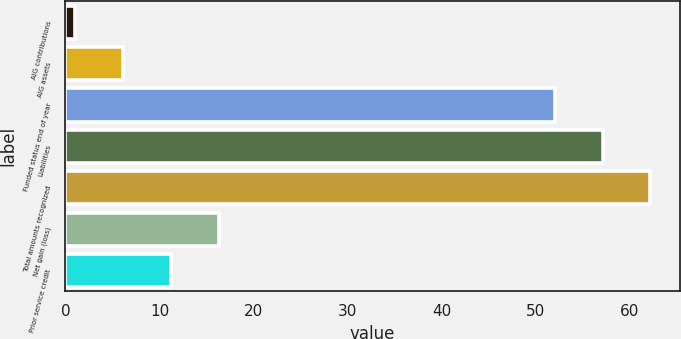Convert chart. <chart><loc_0><loc_0><loc_500><loc_500><bar_chart><fcel>AIG contributions<fcel>AIG assets<fcel>Funded status end of year<fcel>Liabilities<fcel>Total amounts recognized<fcel>Net gain (loss)<fcel>Prior service credit<nl><fcel>1<fcel>6.1<fcel>52<fcel>57.1<fcel>62.2<fcel>16.3<fcel>11.2<nl></chart> 